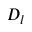Convert formula to latex. <formula><loc_0><loc_0><loc_500><loc_500>D _ { l }</formula> 